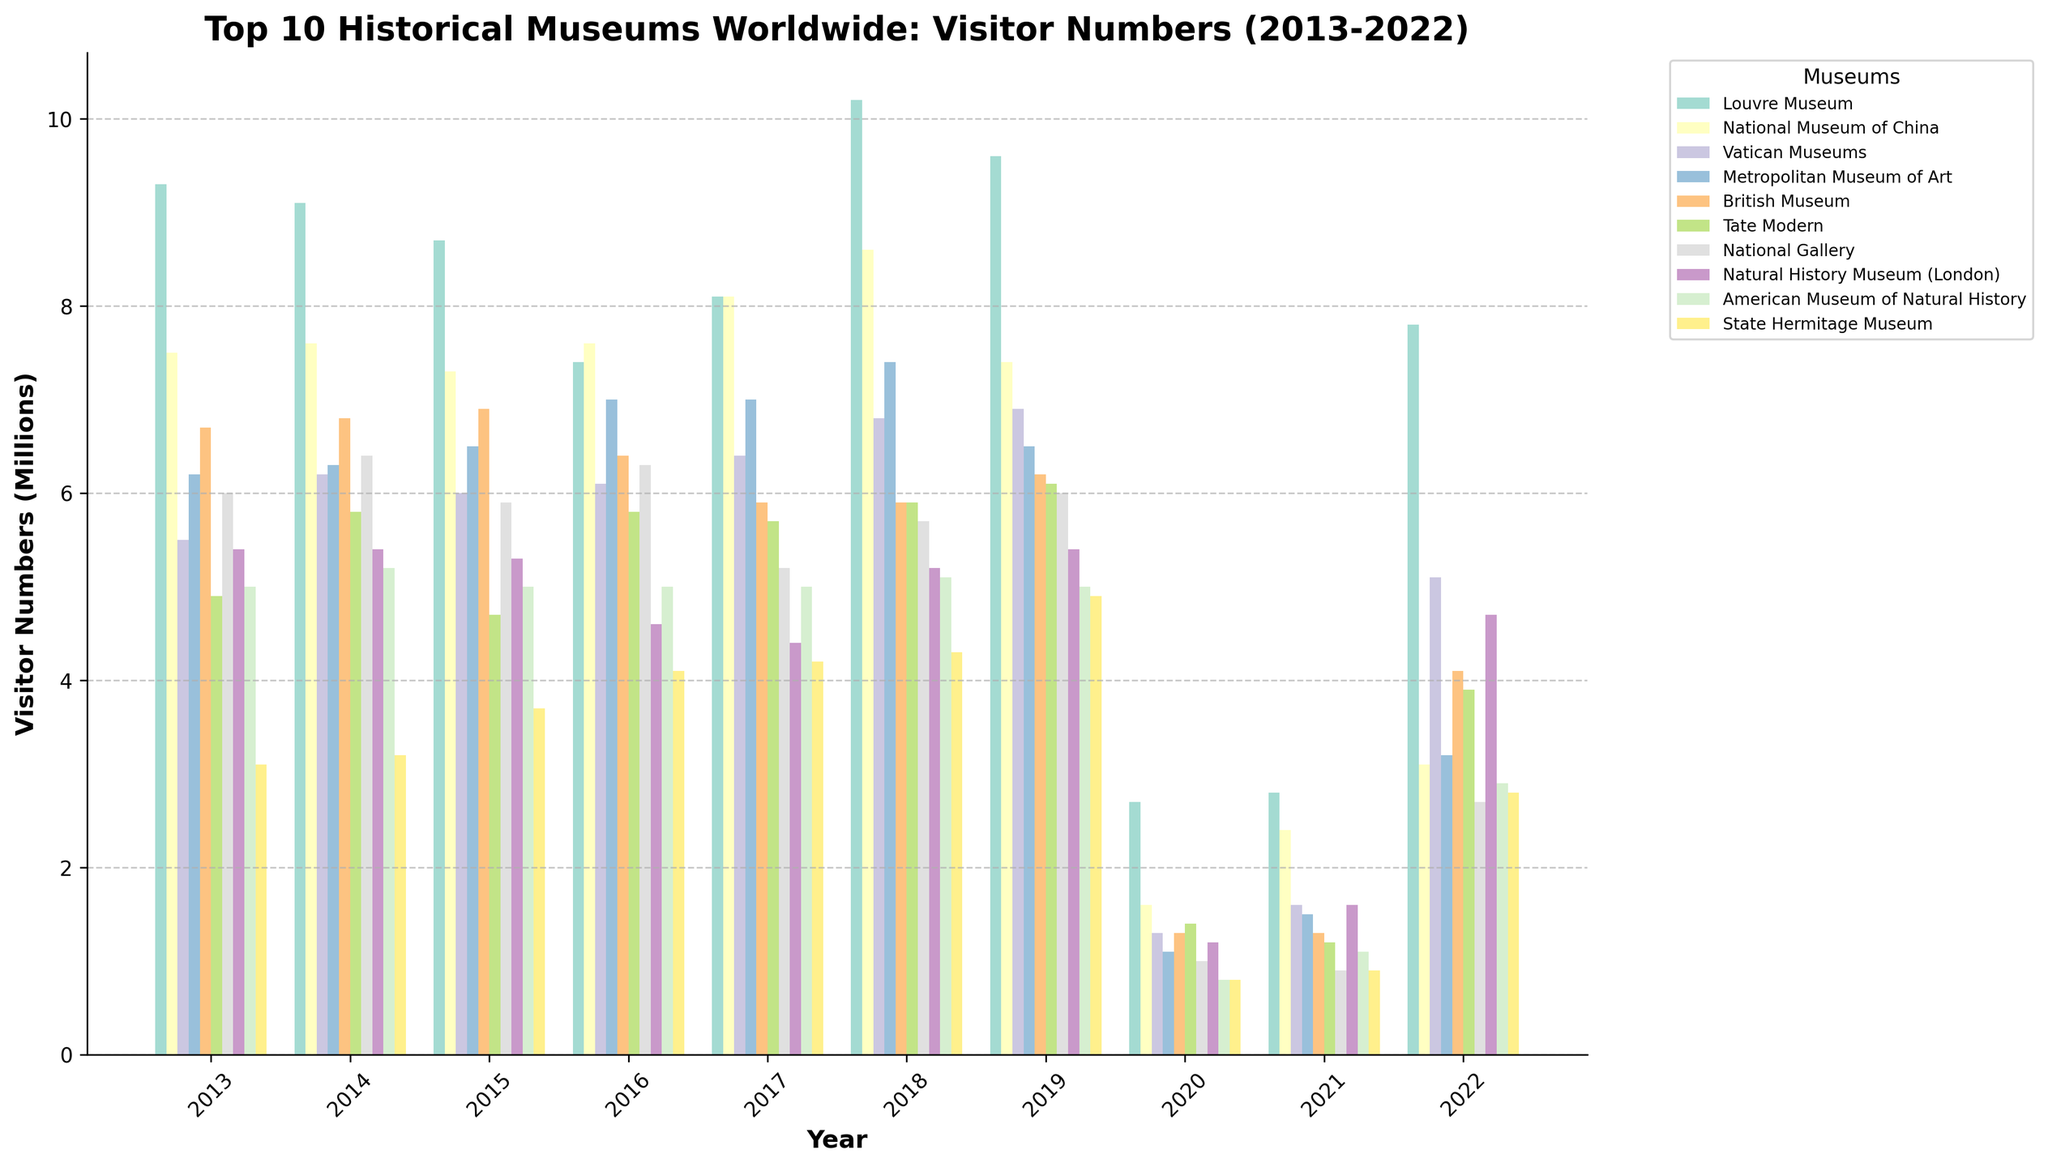What is the overall trend of visitor numbers for the Louvre Museum from 2013 to 2022? The visitor numbers for the Louvre Museum started at 9.3 million in 2013, fluctuated slightly until they dipped drastically to 2.7 million in 2020 due to the pandemic, and then partially recovered to 7.8 million in 2022.
Answer: Fluctuates, dips in 2020, partial recovery in 2022 Which museum had the highest visitor numbers in 2018, and what was the approximate value? In 2018, the Louvre Museum had the highest visitor numbers with approximately 10.2 million visitors.
Answer: Louvre Museum, 10.2 million How did the visitor numbers of the National Museum of China change from 2019 to 2022? The visitor numbers at the National Museum of China decreased from 7.4 million in 2019 to 1.6 million in 2020, and then gradually increased to 3.1 million in 2022.
Answer: Decreased, then increased Compare the visitor numbers of the Vatican Museums and the British Museum in 2021. Which had more visitors, and by how much? In 2021, the Vatican Museums had 1.6 million visitors, while the British Museum had 1.3 million visitors. Therefore, the Vatican Museums had 0.3 million more visitors than the British Museum.
Answer: Vatican Museums by 0.3 million Which museum showed the steepest decline in visitor numbers from 2019 to 2020? The Metropolitan Museum of Art showed the steepest decline from 6.5 million visitors in 2019 to 1.1 million in 2020.
Answer: Metropolitan Museum of Art Identify the museum with the smallest amount of change in visitor numbers between 2020 and 2022. The Tate Modern had a relatively smaller change in visitor numbers, going from 1.4 million in 2020 to 3.9 million in 2022.
Answer: Tate Modern During which years did the Natural History Museum (London) witness a decrease to below 5 million visitors before the pandemic? The Natural History Museum (London) had fewer than 5 million visitors in 2016 (4.6 million) and 2017 (4.4 million).
Answer: 2016, 2017 What was the average number of visitors to the American Museum of Natural History in the decade covered? Summing the visitors (5.0, 5.2, 5.0, 5.0, 5.0, 5.1, 5.0, 0.8, 1.1, 2.9) results in 40.1 million visitors over 10 years. Dividing by 10 gives an average of 4.01 million visitors per year.
Answer: 4.01 million Which museums had visitor numbers below 1 million in 2020, and what were their visitor counts? In 2020, the National Gallery had 0.9 million visitors, American Museum of Natural History had 0.8 million visitors, and State Hermitage Museum had 0.8 million visitors.
Answer: National Gallery, 0.9; American Museum of Natural History, 0.8; State Hermitage Museum, 0.8 Compare the visitor recovery between the Louvre Museum and the National Museum of China from 2020 to 2022. Which museum showed a larger absolute increase in visitors? The Louvre Museum increased from 2.7 million in 2020 to 7.8 million in 2022, a 5.1 million increase. The National Museum of China increased from 1.6 million to 3.1 million, a 1.5 million increase. The Louvre Museum showed a larger absolute increase.
Answer: Louvre Museum, 5.1 million increase 